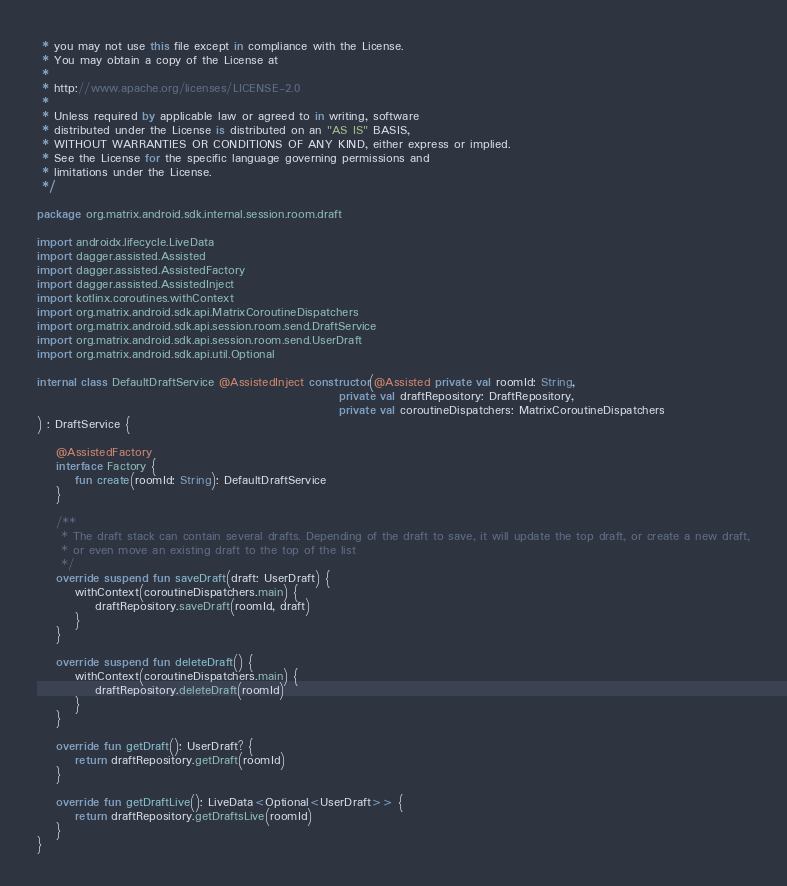<code> <loc_0><loc_0><loc_500><loc_500><_Kotlin_> * you may not use this file except in compliance with the License.
 * You may obtain a copy of the License at
 *
 * http://www.apache.org/licenses/LICENSE-2.0
 *
 * Unless required by applicable law or agreed to in writing, software
 * distributed under the License is distributed on an "AS IS" BASIS,
 * WITHOUT WARRANTIES OR CONDITIONS OF ANY KIND, either express or implied.
 * See the License for the specific language governing permissions and
 * limitations under the License.
 */

package org.matrix.android.sdk.internal.session.room.draft

import androidx.lifecycle.LiveData
import dagger.assisted.Assisted
import dagger.assisted.AssistedFactory
import dagger.assisted.AssistedInject
import kotlinx.coroutines.withContext
import org.matrix.android.sdk.api.MatrixCoroutineDispatchers
import org.matrix.android.sdk.api.session.room.send.DraftService
import org.matrix.android.sdk.api.session.room.send.UserDraft
import org.matrix.android.sdk.api.util.Optional

internal class DefaultDraftService @AssistedInject constructor(@Assisted private val roomId: String,
                                                               private val draftRepository: DraftRepository,
                                                               private val coroutineDispatchers: MatrixCoroutineDispatchers
) : DraftService {

    @AssistedFactory
    interface Factory {
        fun create(roomId: String): DefaultDraftService
    }

    /**
     * The draft stack can contain several drafts. Depending of the draft to save, it will update the top draft, or create a new draft,
     * or even move an existing draft to the top of the list
     */
    override suspend fun saveDraft(draft: UserDraft) {
        withContext(coroutineDispatchers.main) {
            draftRepository.saveDraft(roomId, draft)
        }
    }

    override suspend fun deleteDraft() {
        withContext(coroutineDispatchers.main) {
            draftRepository.deleteDraft(roomId)
        }
    }

    override fun getDraft(): UserDraft? {
        return draftRepository.getDraft(roomId)
    }

    override fun getDraftLive(): LiveData<Optional<UserDraft>> {
        return draftRepository.getDraftsLive(roomId)
    }
}
</code> 